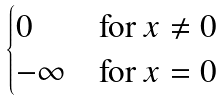Convert formula to latex. <formula><loc_0><loc_0><loc_500><loc_500>\begin{cases} 0 & \text {for $x \neq 0$} \\ - \infty & \text {for $x = 0$} \end{cases}</formula> 